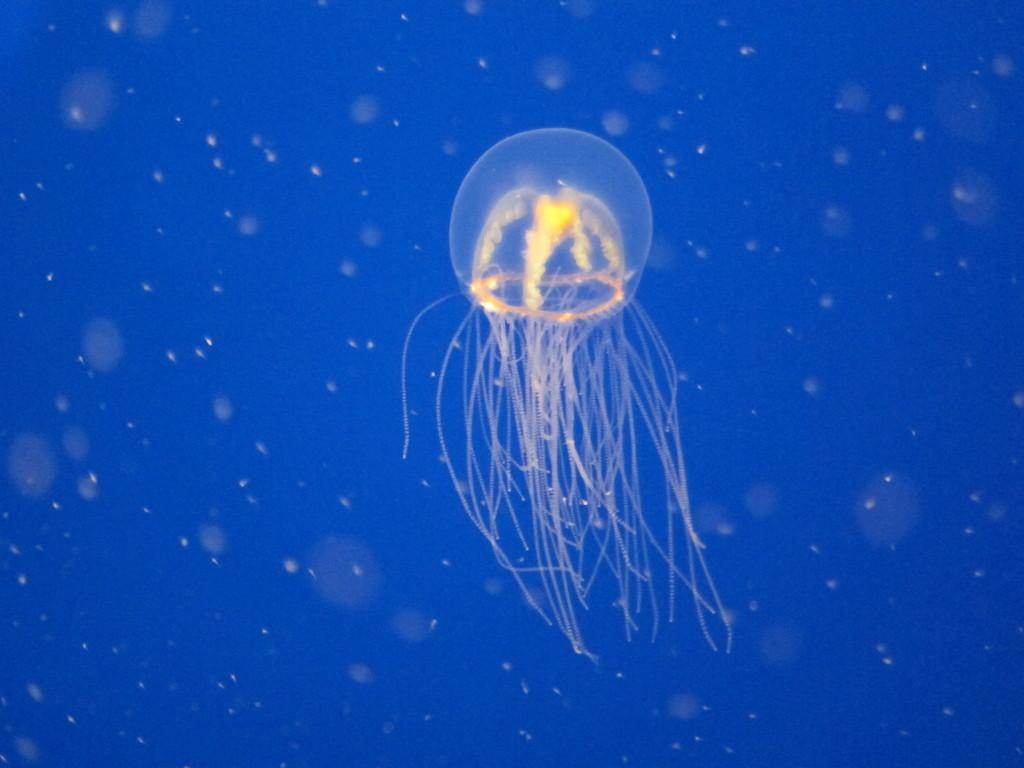What type of environment is shown in the image? The image depicts an underwater environment. What marine creature can be seen in the image? There is a jellyfish in the image. What type of sock is the woman wearing in the image? There is no woman or sock present in the image, as it depicts an underwater environment with a jellyfish. 